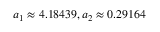Convert formula to latex. <formula><loc_0><loc_0><loc_500><loc_500>a _ { 1 } \approx 4 . 1 8 4 3 9 , a _ { 2 } \approx 0 . 2 9 1 6 4</formula> 